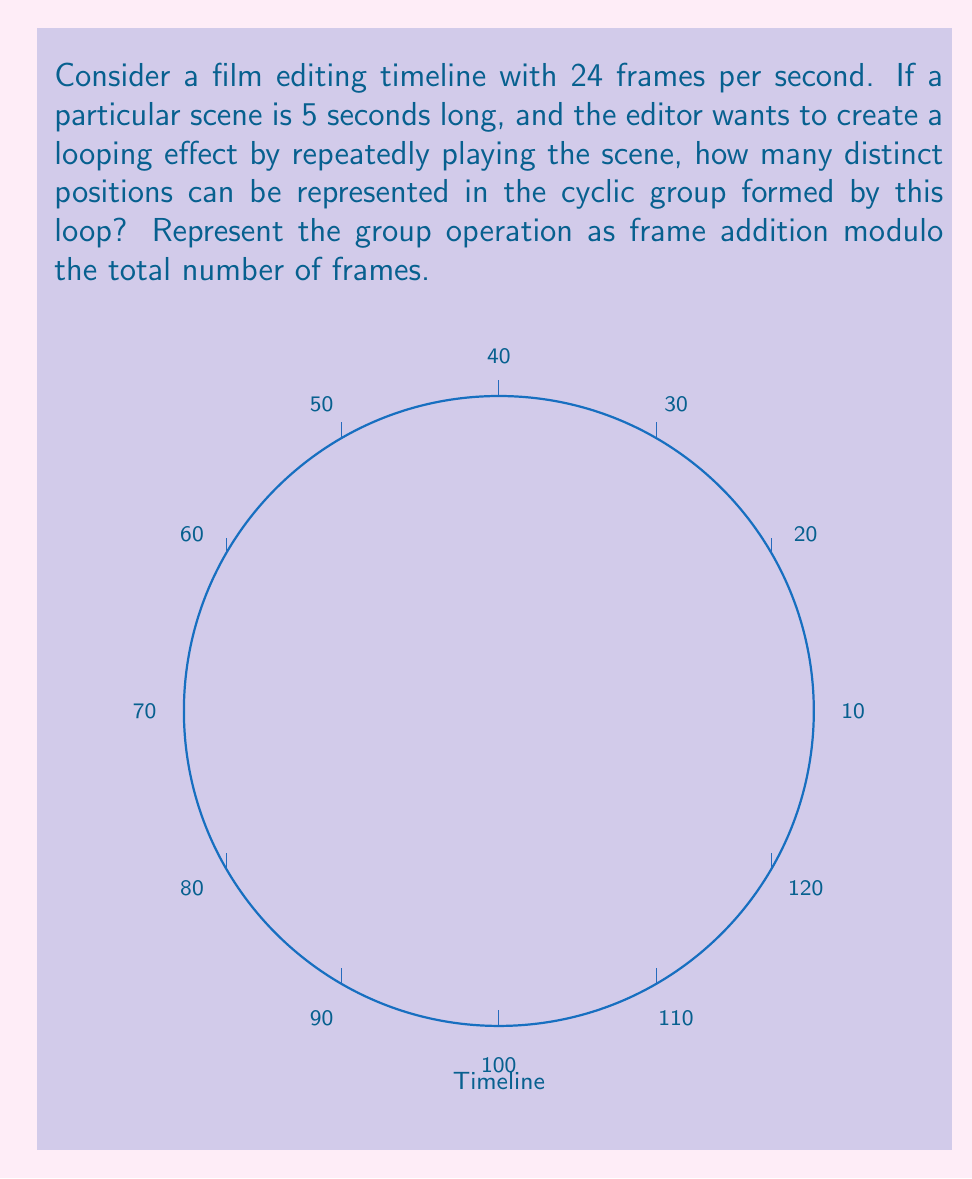Teach me how to tackle this problem. Let's approach this step-by-step:

1) First, we need to calculate the total number of frames in the 5-second scene:
   $$ 24 \text{ frames/second} \times 5 \text{ seconds} = 120 \text{ frames} $$

2) The cyclic group formed by this loop will have an order equal to the total number of frames. Let's call this group $G$.

3) In group theory, a cyclic group of order $n$ is isomorphic to the additive group of integers modulo $n$, denoted as $\mathbb{Z}_n$.

4) Therefore, our group $G$ is isomorphic to $\mathbb{Z}_{120}$.

5) In $\mathbb{Z}_{120}$, the elements are $\{0, 1, 2, ..., 119\}$, where each number represents a frame in the timeline.

6) The group operation (frame addition) is defined as:
   $$ a \oplus b = (a + b) \bmod 120 $$
   where $a$ and $b$ are frame positions.

7) This group has exactly 120 distinct elements, each representing a unique position in the looping timeline.

Thus, the cyclic group structure of this film editing timeline can represent 120 distinct positions.
Answer: 120 